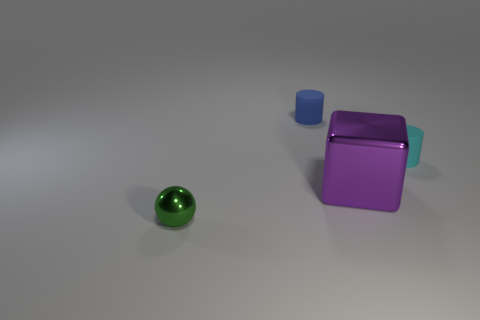What is the color of the small rubber object on the left side of the tiny rubber thing in front of the rubber object on the left side of the purple block?
Make the answer very short. Blue. Does the small cyan thing have the same material as the object behind the small cyan object?
Your response must be concise. Yes. There is a cyan object that is the same shape as the blue object; what size is it?
Ensure brevity in your answer.  Small. Are there an equal number of cyan cylinders that are left of the purple metallic thing and large blocks behind the tiny cyan rubber cylinder?
Offer a terse response. Yes. Are there the same number of green spheres right of the cyan cylinder and blue cylinders?
Keep it short and to the point. No. Is the size of the blue cylinder the same as the rubber cylinder right of the blue cylinder?
Your answer should be very brief. Yes. The rubber object on the left side of the cyan matte thing has what shape?
Offer a very short reply. Cylinder. Is there any other thing that has the same shape as the blue matte thing?
Keep it short and to the point. Yes. Are any brown metal cylinders visible?
Offer a terse response. No. There is a cylinder that is left of the cube; does it have the same size as the rubber thing in front of the small blue matte cylinder?
Make the answer very short. Yes. 